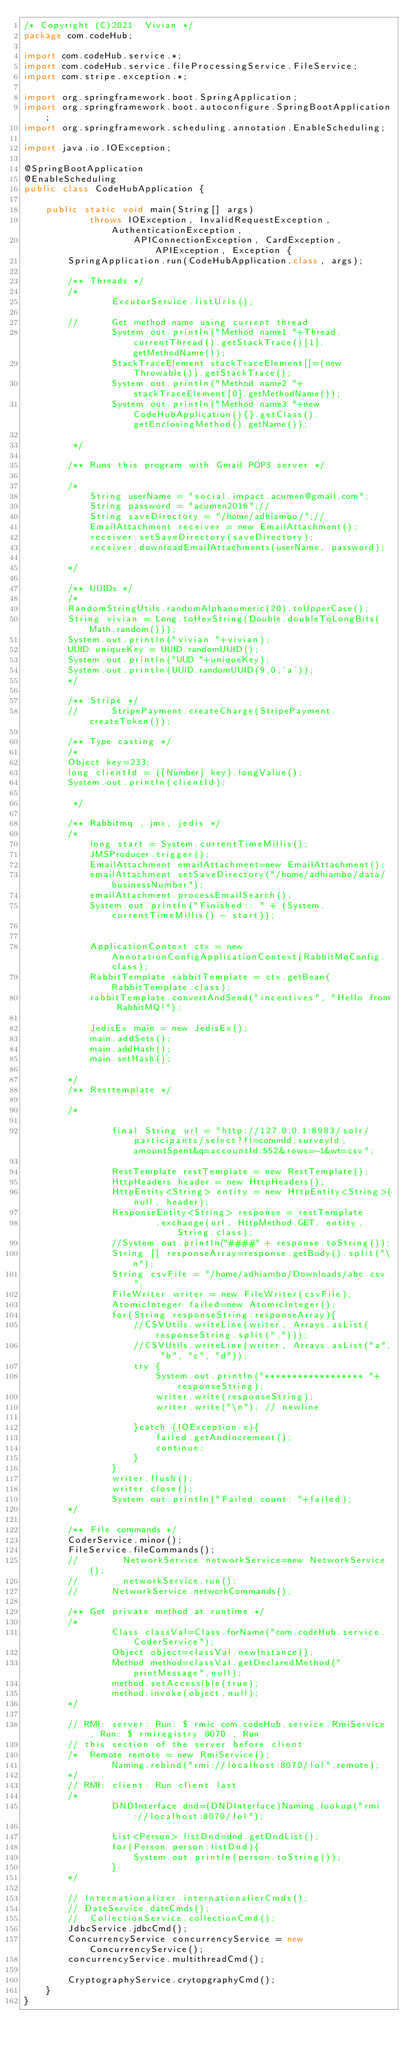Convert code to text. <code><loc_0><loc_0><loc_500><loc_500><_Java_>/* Copyright (C)2021  Vivian */
package com.codeHub;

import com.codeHub.service.*;
import com.codeHub.service.fileProcessingService.FileService;
import com.stripe.exception.*;

import org.springframework.boot.SpringApplication;
import org.springframework.boot.autoconfigure.SpringBootApplication;
import org.springframework.scheduling.annotation.EnableScheduling;

import java.io.IOException;

@SpringBootApplication
@EnableScheduling
public class CodeHubApplication {

    public static void main(String[] args)
            throws IOException, InvalidRequestException, AuthenticationException,
                    APIConnectionException, CardException, APIException, Exception {
        SpringApplication.run(CodeHubApplication.class, args);

        /** Threads */
        /*
        		ExcutorService.listUrls();

        //		Get method name using current thread
        		System.out.println("Method name1 "+Thread.currentThread().getStackTrace()[1].getMethodName());
        		StackTraceElement stackTraceElement[]=(new Throwable()).getStackTrace();
        		System.out.println("Method name2 "+stackTraceElement[0].getMethodName());
        		System.out.println("Method name3 "+new CodeHubApplication(){}.getClass().getEnclosingMethod().getName());

         */

        /** Runs this program with Gmail POP3 server */

        /*
        	String userName = "social.impact.acumen@gmail.com";
        	String password = "acumen2016";//
        	String saveDirectory = "/home/adhiambo/";//
        	EmailAttachment receiver = new EmailAttachment();
        	receiver.setSaveDirectory(saveDirectory);
        	receiver.downloadEmailAttachments(userName, password);

        */

        /** UUIDs */
        /*
        RandomStringUtils.randomAlphanumeric(20).toUpperCase();
        String vivian = Long.toHexString(Double.doubleToLongBits(Math.random()));
        System.out.println("vivian "+vivian);
        UUID uniqueKey = UUID.randomUUID();
        System.out.println("UUD "+uniqueKey);
        System.out.println(UUID.randomUUID(9,0,'a'));
        */

        /** Stripe */
        //		StripePayment.createCharge(StripePayment.createToken());

        /** Type casting */
        /*
        Object key=233;
        long clientId = ((Number) key).longValue();
        System.out.println(clientId);

         */

        /** Rabbitmq , jmx, jedis */
        /*
        	long start = System.currentTimeMillis();
        	JMSProducer.trigger();
        	EmailAttachment emailAttachment=new EmailAttachment();
        	emailAttachment.setSaveDirectory("/home/adhiambo/data/businessNumber");
        	emailAttachment.processEmailSearch();
        	System.out.println("Finished:: " + (System.currentTimeMillis() - start));


        	ApplicationContext ctx = new AnnotationConfigApplicationContext(RabbitMqConfig.class);
        	RabbitTemplate rabbitTemplate = ctx.getBean(RabbitTemplate.class);
        	rabbitTemplate.convertAndSend("incentives", "Hello from RabbitMQ!");

        	JedisEx main = new JedisEx();
        	main.addSets();
        	main.addHash();
        	main.setHash();

        */
        /** Resttemplate */

        /*

        		final String url = "http://127.0.0.1:8983/solr/participants/select?fl=commId,surveyId,amountSpent&q=accountId:552&rows=-1&wt=csv";

        		RestTemplate restTemplate = new RestTemplate();
        		HttpHeaders header = new HttpHeaders();
        		HttpEntity<String> entity = new HttpEntity<String>(null, header);
        		ResponseEntity<String> response = restTemplate
        				.exchange(url, HttpMethod.GET, entity, String.class);
        		//System.out.println("####" + response.toString());
        		String [] responseArray=response.getBody().split("\n");
        		String csvFile = "/home/adhiambo/Downloads/abc.csv";
        		FileWriter writer = new FileWriter(csvFile);
        		AtomicInteger failed=new AtomicInteger();
        		for(String responseString:responseArray){
        			//CSVUtils.writeLine(writer, Arrays.asList(responseString.split(",")));
        			//CSVUtils.writeLine(writer, Arrays.asList("a", "b", "c", "d"));
        			try {
        				System.out.println("****************** "+responseString);
        				writer.write(responseString);
        				writer.write("\n"); // newline

        			}catch (IOException e){
        				failed.getAndIncrement();
        				continue;
        			}
        		}
        		writer.flush();
        		writer.close();
        		System.out.println("Failed count: "+failed);
        */

        /** File commands */
        CoderService.minor();
        FileService.fileCommands();
        //        NetworkService networkService=new NetworkService();
        //        networkService.run();
        //		NetworkService.networkCommands();

        /** Get private method at runtime */
        /*
        		Class classVal=Class.forName("com.codeHub.service.CoderService");
        		Object object=classVal.newInstance();
        		Method method=classVal.getDeclaredMethod("printMessage",null);
        		method.setAccessible(true);
        		method.invoke(object,null);
        */

        // RMI: server: Run: $ rmic com.codeHub.service.RmiService , Run: $ rmiregistry 8070 , Run
        // this section of the server before client
        /*	Remote remote = new RmiService();
        		Naming.rebind("rmi://localhost:8070/lol",remote);
        */
        // RMI: client: Run client last
        /*
        		DNDInterface dnd=(DNDInterface)Naming.lookup("rmi://localhost:8070/lol");

        		List<Person> listDnd=dnd.getDndList();
        		for(Person person:listDnd){
        			System.out.println(person.toString());
        		}
        */

        // Internationalizer.internationalierCmds();
        // DateService.dateCmds();
        //	CollectionService.collectionCmd();
        JdbcService.jdbcCmd();
        ConcurrencyService concurrencyService = new ConcurrencyService();
        concurrencyService.multithreadCmd();

        CryptographyService.crytopgraphyCmd();
    }
}
</code> 